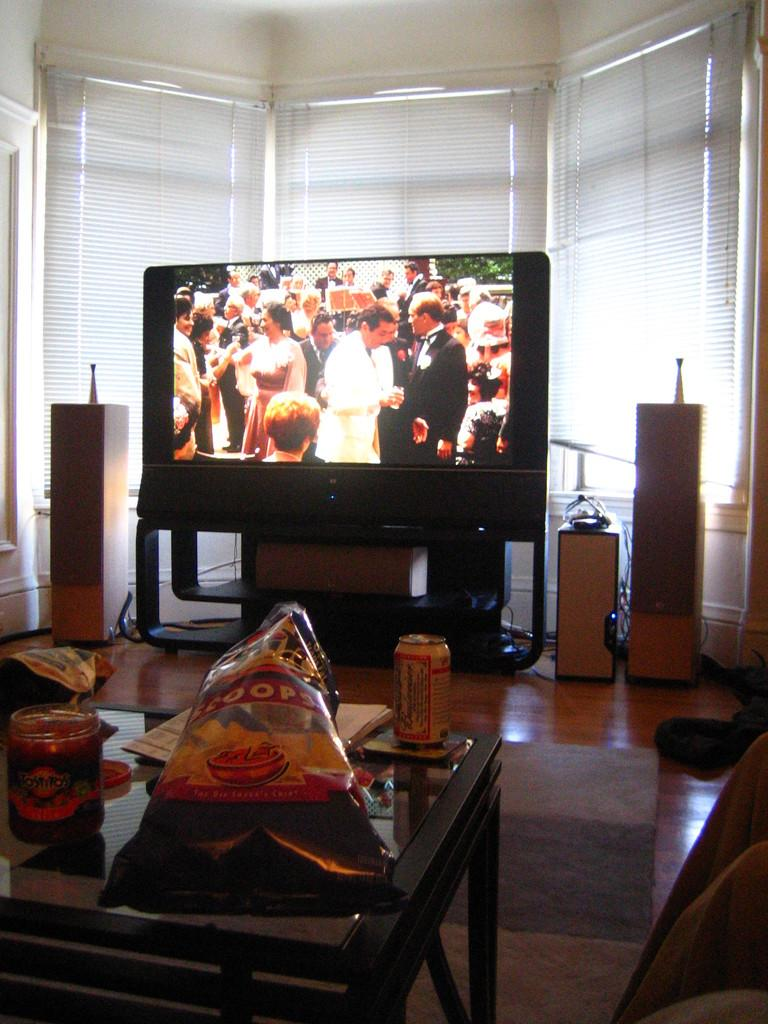What type of furniture is present in the image? There is a table in the image. What items can be seen on the table? There are packets and a tin can on the table. Are there any other objects on the table? Yes, there are other objects on the table. What electronic device is visible in the image? There is a TV in the image. What is lying on the floor in the image? There are window blinds on the floor. What type of stone is used to build the TV in the image? There is no stone used to build the TV in the image; it is an electronic device made of various materials. 